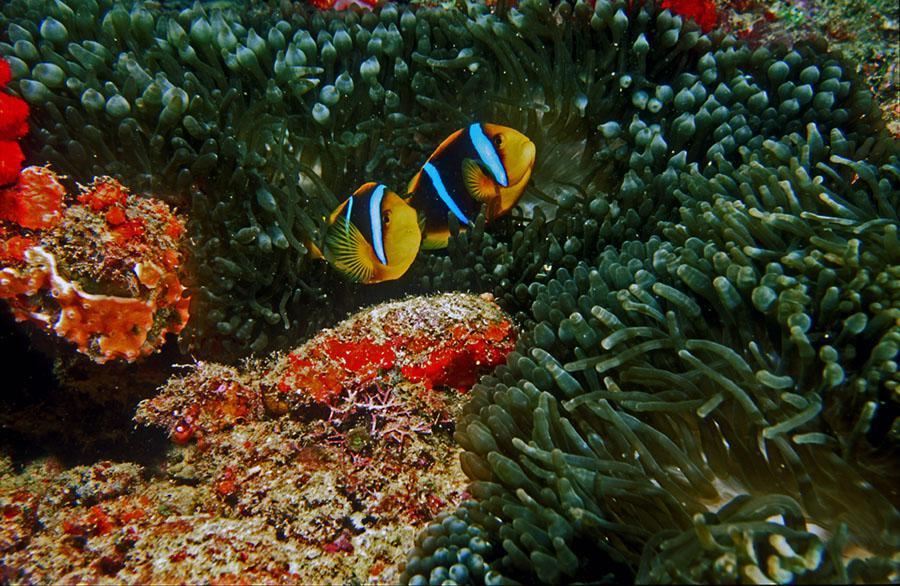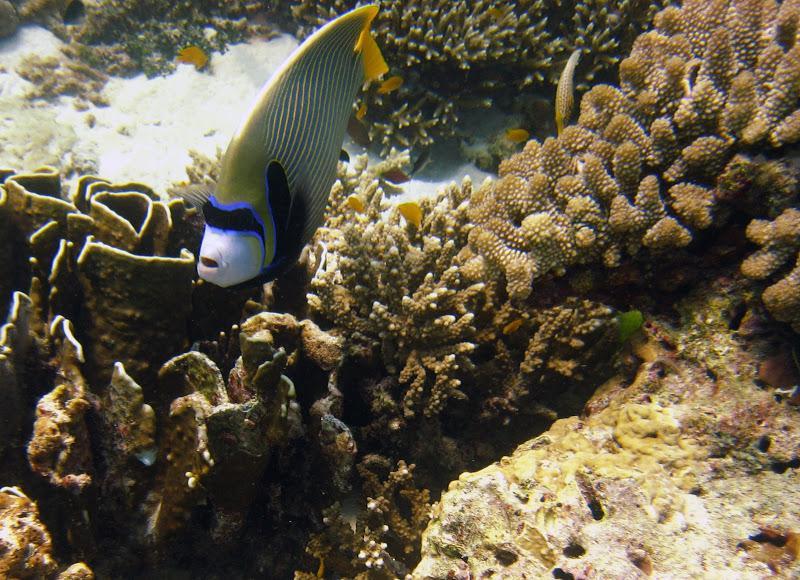The first image is the image on the left, the second image is the image on the right. Evaluate the accuracy of this statement regarding the images: "One image includes two close together fish that are bright orange with white stripe, and the other image includes a yellower fish with white stripes.". Is it true? Answer yes or no. No. 